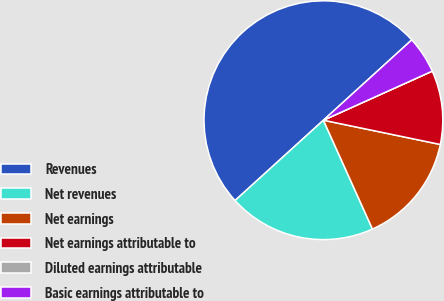Convert chart. <chart><loc_0><loc_0><loc_500><loc_500><pie_chart><fcel>Revenues<fcel>Net revenues<fcel>Net earnings<fcel>Net earnings attributable to<fcel>Diluted earnings attributable<fcel>Basic earnings attributable to<nl><fcel>50.0%<fcel>20.0%<fcel>15.0%<fcel>10.0%<fcel>0.0%<fcel>5.0%<nl></chart> 